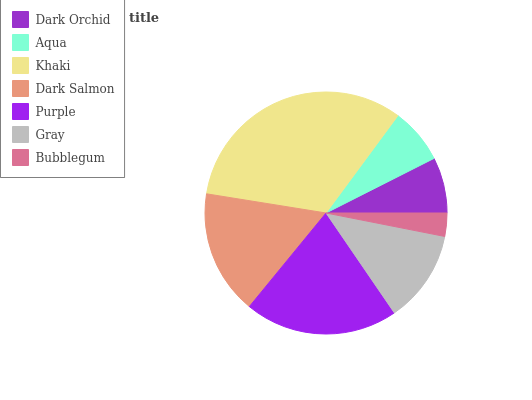Is Bubblegum the minimum?
Answer yes or no. Yes. Is Khaki the maximum?
Answer yes or no. Yes. Is Aqua the minimum?
Answer yes or no. No. Is Aqua the maximum?
Answer yes or no. No. Is Dark Orchid greater than Aqua?
Answer yes or no. Yes. Is Aqua less than Dark Orchid?
Answer yes or no. Yes. Is Aqua greater than Dark Orchid?
Answer yes or no. No. Is Dark Orchid less than Aqua?
Answer yes or no. No. Is Gray the high median?
Answer yes or no. Yes. Is Gray the low median?
Answer yes or no. Yes. Is Bubblegum the high median?
Answer yes or no. No. Is Purple the low median?
Answer yes or no. No. 